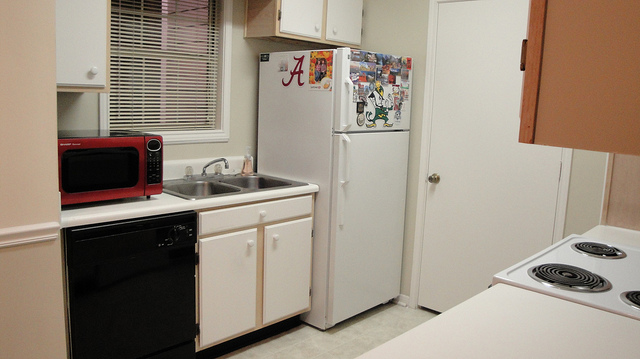Please transcribe the text information in this image. A 